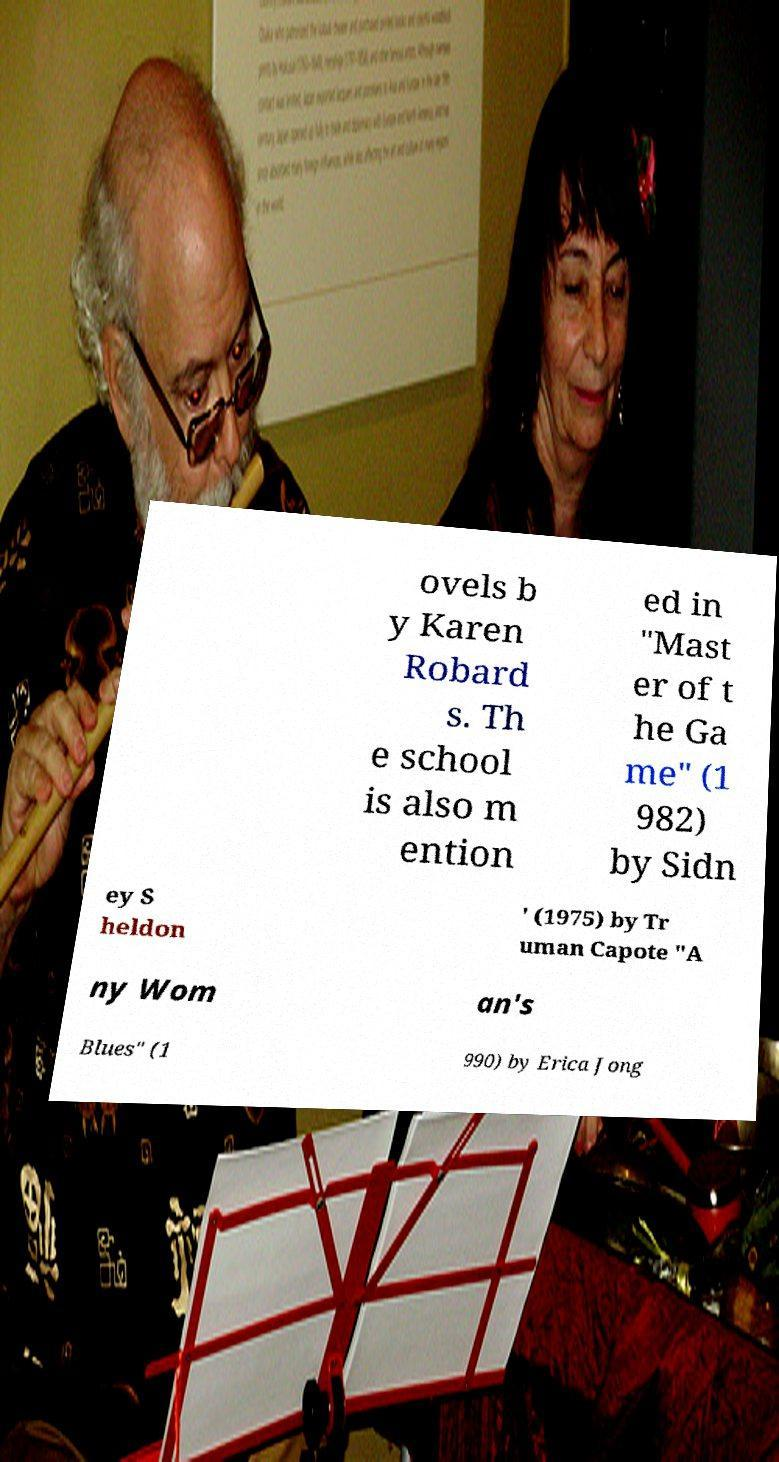Can you accurately transcribe the text from the provided image for me? ovels b y Karen Robard s. Th e school is also m ention ed in "Mast er of t he Ga me" (1 982) by Sidn ey S heldon ' (1975) by Tr uman Capote "A ny Wom an's Blues" (1 990) by Erica Jong 